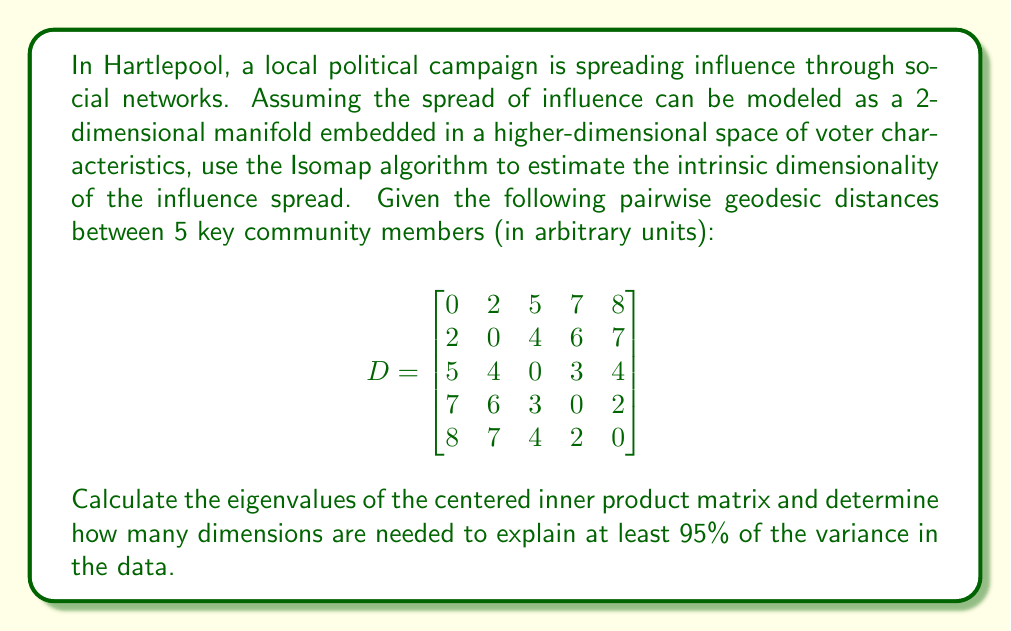Help me with this question. To solve this problem, we'll follow these steps:

1) First, we need to create the centered inner product matrix. This involves:
   a) Squaring each element of the distance matrix
   b) Double centering the resulting matrix

2) Calculate the eigenvalues of the centered inner product matrix

3) Determine how many dimensions are needed to explain 95% of the variance

Step 1:
a) Square each element of D:
$$
D^2 = \begin{bmatrix}
0 & 4 & 25 & 49 & 64 \\
4 & 0 & 16 & 36 & 49 \\
25 & 16 & 0 & 9 & 16 \\
49 & 36 & 9 & 0 & 4 \\
64 & 49 & 16 & 4 & 0
\end{bmatrix}
$$

b) Double center the matrix:
$B = -\frac{1}{2}(I - \frac{1}{n}11^T)D^2(I - \frac{1}{n}11^T)$

Where I is the identity matrix, 1 is a vector of ones, and n = 5.

After calculation:
$$
B \approx \begin{bmatrix}
13.96 & 7.56 & -3.64 & -8.24 & -9.64 \\
7.56 & 10.76 & 1.16 & -6.04 & -13.44 \\
-3.64 & 1.16 & 6.76 & 1.76 & -6.04 \\
-8.24 & -6.04 & 1.76 & 7.16 & 5.36 \\
-9.64 & -13.44 & -6.04 & 5.36 & 23.76
\end{bmatrix}
$$

Step 2:
Calculate the eigenvalues of B. Using a numerical method, we get:
$\lambda_1 \approx 37.76$
$\lambda_2 \approx 23.51$
$\lambda_3 \approx 0.13$
$\lambda_4 \approx 0.00$
$\lambda_5 \approx 0.00$

Step 3:
To determine how many dimensions explain 95% of the variance, we calculate the cumulative proportion of variance explained:

Total variance = $\sum_{i=1}^5 \lambda_i = 61.40$

Proportion explained by first dimension: $37.76 / 61.40 = 0.6150$ or 61.50%
Proportion explained by first two dimensions: $(37.76 + 23.51) / 61.40 = 0.9980$ or 99.80%

Since the first two dimensions explain more than 95% of the variance, we need 2 dimensions.
Answer: 2 dimensions 